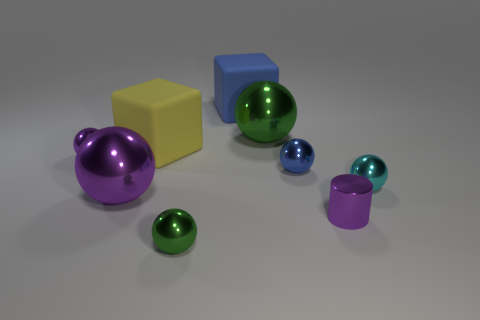Do the cyan ball and the blue matte block have the same size?
Ensure brevity in your answer.  No. What number of other objects are the same shape as the yellow thing?
Make the answer very short. 1. Is the shape of the tiny blue shiny object the same as the large purple metallic thing?
Make the answer very short. Yes. Are there any tiny green shiny balls to the right of the large blue block?
Make the answer very short. No. How many objects are either cyan matte cylinders or large purple metal objects?
Give a very brief answer. 1. How many other things are the same size as the blue metallic thing?
Give a very brief answer. 4. What number of objects are in front of the cyan metal sphere and right of the blue sphere?
Ensure brevity in your answer.  1. There is a block behind the big green thing; does it have the same size as the green sphere in front of the large green ball?
Provide a succinct answer. No. There is a green ball that is behind the cyan sphere; what size is it?
Make the answer very short. Large. How many objects are small metal spheres right of the large yellow rubber block or metallic things that are behind the tiny metal cylinder?
Ensure brevity in your answer.  6. 